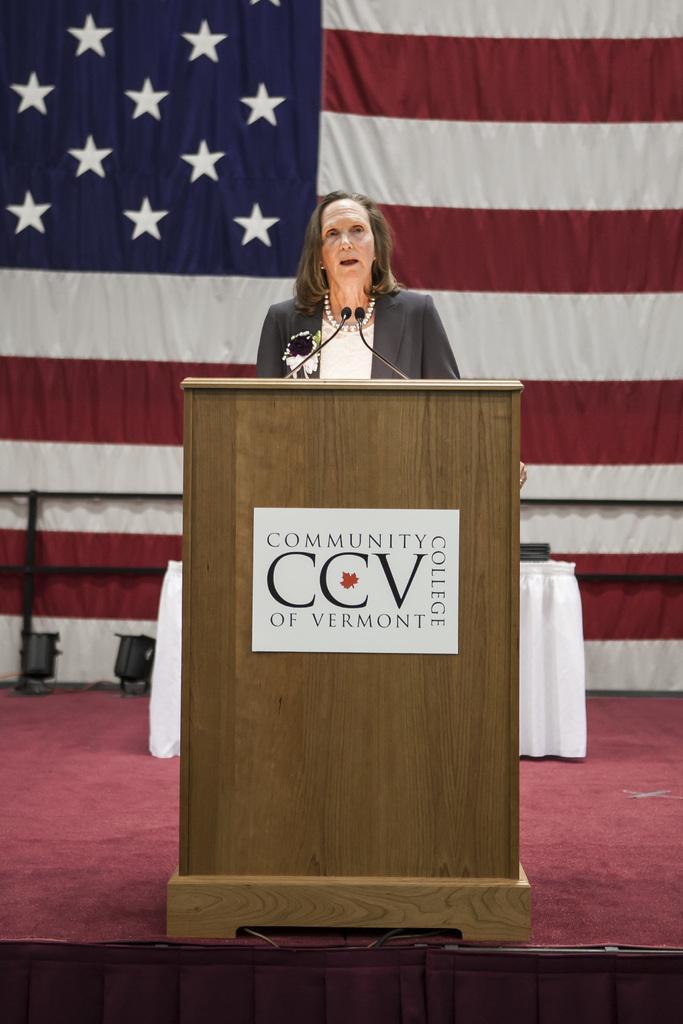Describe this image in one or two sentences. In this image I can see a woman wearing white and black colored dress is standing behind the podium which is brown in color. I can see two microphones in front of her. In the background I can see a flag which is white, blue and red in color and the red colored stage. 